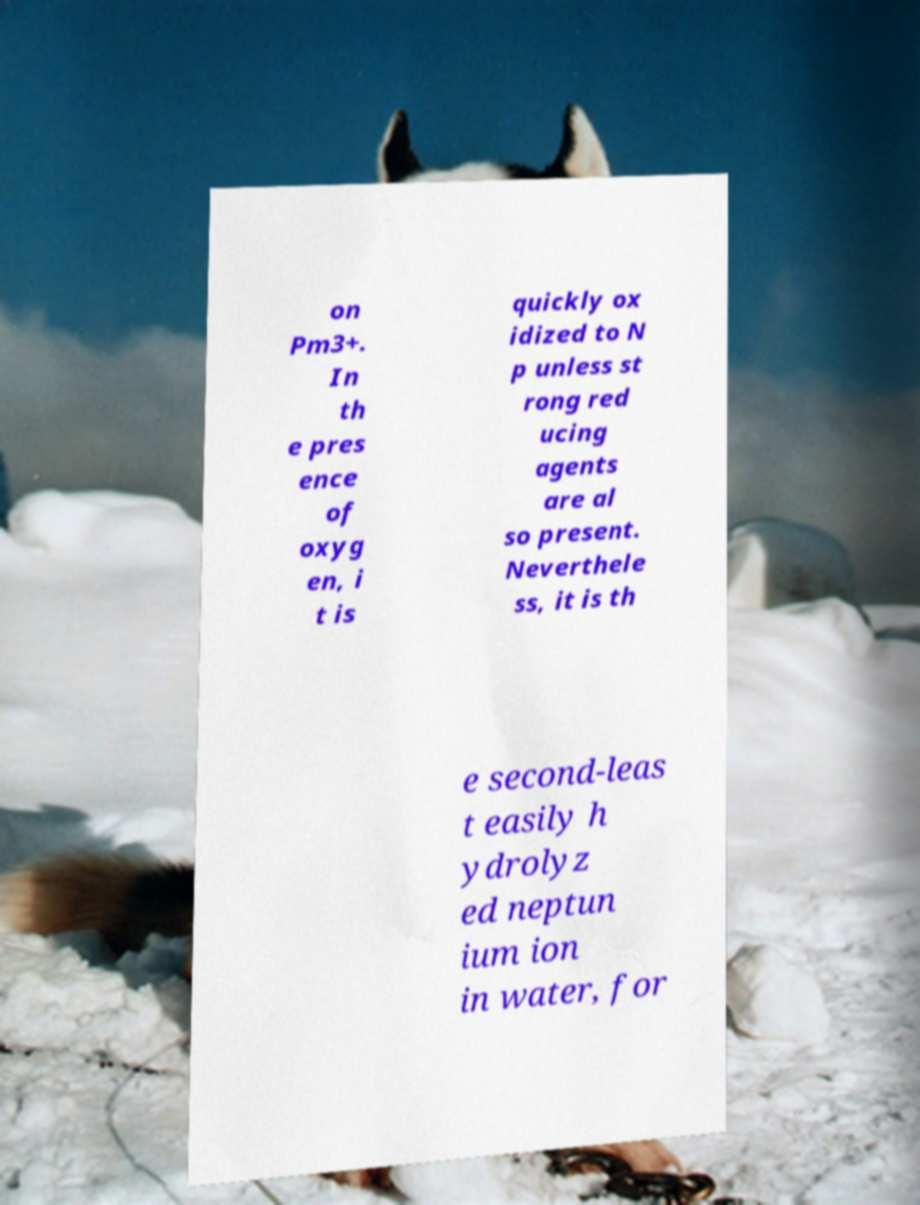Please identify and transcribe the text found in this image. on Pm3+. In th e pres ence of oxyg en, i t is quickly ox idized to N p unless st rong red ucing agents are al so present. Neverthele ss, it is th e second-leas t easily h ydrolyz ed neptun ium ion in water, for 